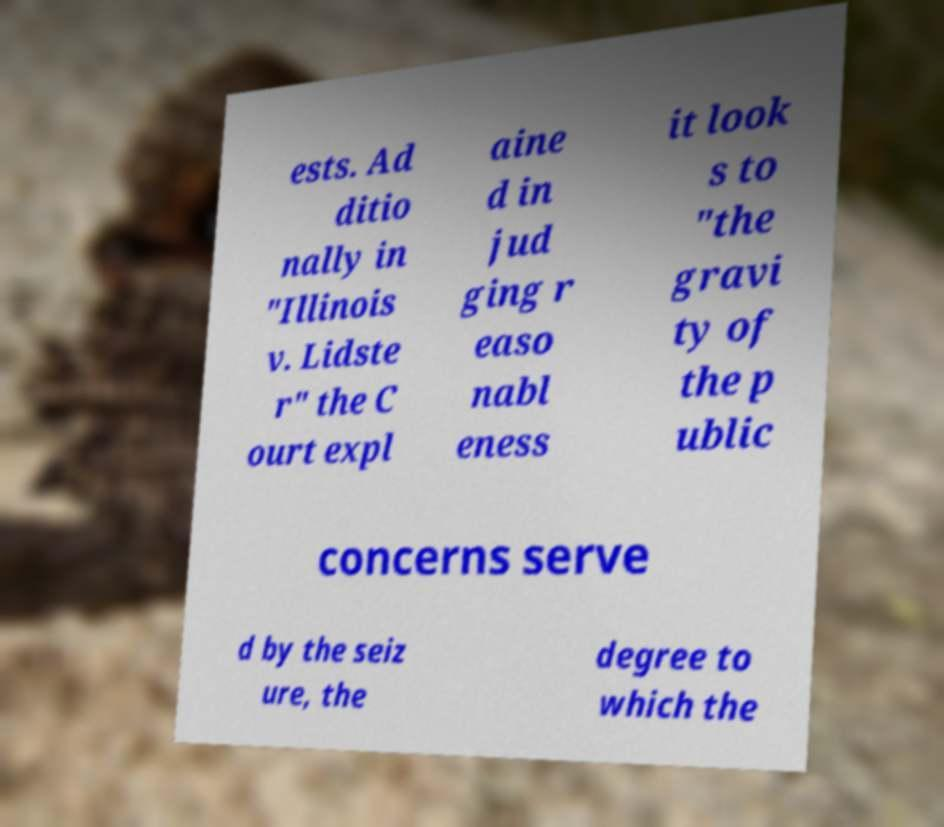Please read and relay the text visible in this image. What does it say? ests. Ad ditio nally in "Illinois v. Lidste r" the C ourt expl aine d in jud ging r easo nabl eness it look s to "the gravi ty of the p ublic concerns serve d by the seiz ure, the degree to which the 